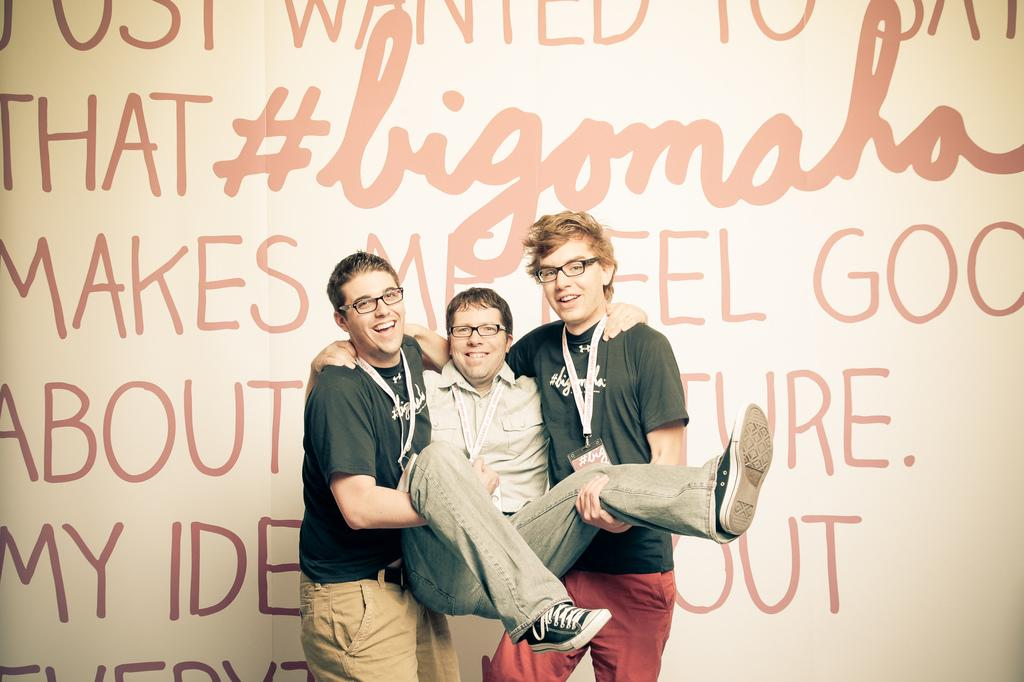How many people are in the image? There are three people in the image. What are the people in the middle of the image wearing? Both persons in the middle of the image are wearing t-shirts. What is the facial expression of the people in the image? All three persons in the image are smiling. What can be seen in the background of the image? In the background, there is a white color wall with texts on it. What type of stocking is the person in the image wearing? There is no mention of stockings in the image, and no person is wearing stockings. How many times does the person in the image sneeze? There is no indication of sneezing in the image, so it cannot be determined how many times the person sneezes. 